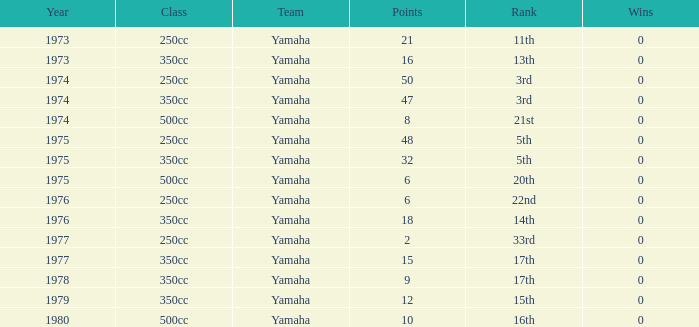How many Points have a Rank of 17th, and Wins larger than 0? 0.0. 